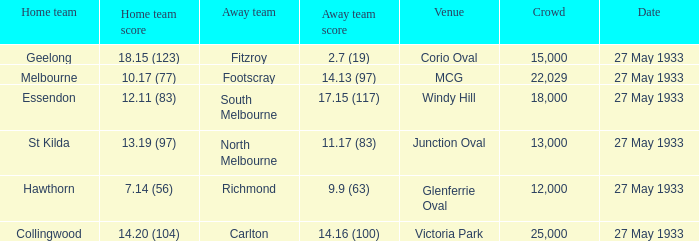In the contest where the away team scored 15000.0. Would you be able to parse every entry in this table? {'header': ['Home team', 'Home team score', 'Away team', 'Away team score', 'Venue', 'Crowd', 'Date'], 'rows': [['Geelong', '18.15 (123)', 'Fitzroy', '2.7 (19)', 'Corio Oval', '15,000', '27 May 1933'], ['Melbourne', '10.17 (77)', 'Footscray', '14.13 (97)', 'MCG', '22,029', '27 May 1933'], ['Essendon', '12.11 (83)', 'South Melbourne', '17.15 (117)', 'Windy Hill', '18,000', '27 May 1933'], ['St Kilda', '13.19 (97)', 'North Melbourne', '11.17 (83)', 'Junction Oval', '13,000', '27 May 1933'], ['Hawthorn', '7.14 (56)', 'Richmond', '9.9 (63)', 'Glenferrie Oval', '12,000', '27 May 1933'], ['Collingwood', '14.20 (104)', 'Carlton', '14.16 (100)', 'Victoria Park', '25,000', '27 May 1933']]} 